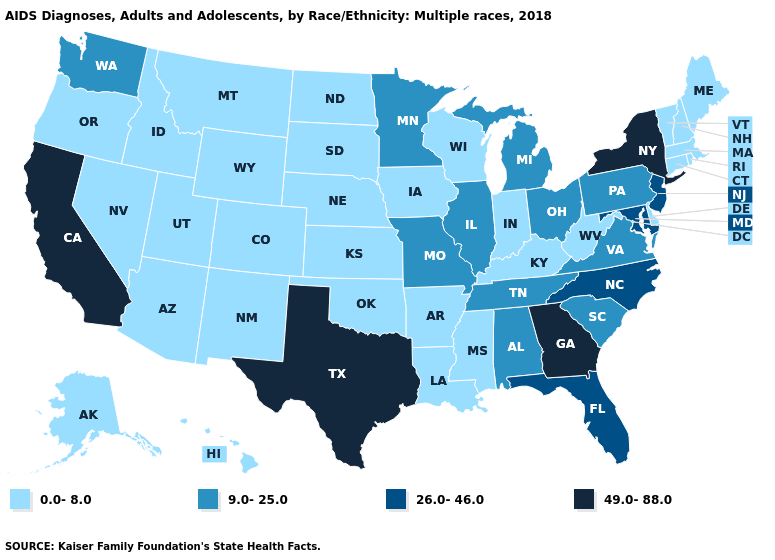What is the value of Wyoming?
Be succinct. 0.0-8.0. What is the lowest value in the USA?
Write a very short answer. 0.0-8.0. Name the states that have a value in the range 0.0-8.0?
Give a very brief answer. Alaska, Arizona, Arkansas, Colorado, Connecticut, Delaware, Hawaii, Idaho, Indiana, Iowa, Kansas, Kentucky, Louisiana, Maine, Massachusetts, Mississippi, Montana, Nebraska, Nevada, New Hampshire, New Mexico, North Dakota, Oklahoma, Oregon, Rhode Island, South Dakota, Utah, Vermont, West Virginia, Wisconsin, Wyoming. What is the value of Louisiana?
Concise answer only. 0.0-8.0. Name the states that have a value in the range 26.0-46.0?
Quick response, please. Florida, Maryland, New Jersey, North Carolina. Name the states that have a value in the range 0.0-8.0?
Write a very short answer. Alaska, Arizona, Arkansas, Colorado, Connecticut, Delaware, Hawaii, Idaho, Indiana, Iowa, Kansas, Kentucky, Louisiana, Maine, Massachusetts, Mississippi, Montana, Nebraska, Nevada, New Hampshire, New Mexico, North Dakota, Oklahoma, Oregon, Rhode Island, South Dakota, Utah, Vermont, West Virginia, Wisconsin, Wyoming. Does the map have missing data?
Write a very short answer. No. What is the value of Connecticut?
Keep it brief. 0.0-8.0. Is the legend a continuous bar?
Keep it brief. No. Does South Carolina have the lowest value in the USA?
Keep it brief. No. Name the states that have a value in the range 26.0-46.0?
Be succinct. Florida, Maryland, New Jersey, North Carolina. What is the value of Arkansas?
Give a very brief answer. 0.0-8.0. Name the states that have a value in the range 9.0-25.0?
Give a very brief answer. Alabama, Illinois, Michigan, Minnesota, Missouri, Ohio, Pennsylvania, South Carolina, Tennessee, Virginia, Washington. What is the value of Alabama?
Give a very brief answer. 9.0-25.0. Which states have the lowest value in the Northeast?
Short answer required. Connecticut, Maine, Massachusetts, New Hampshire, Rhode Island, Vermont. 